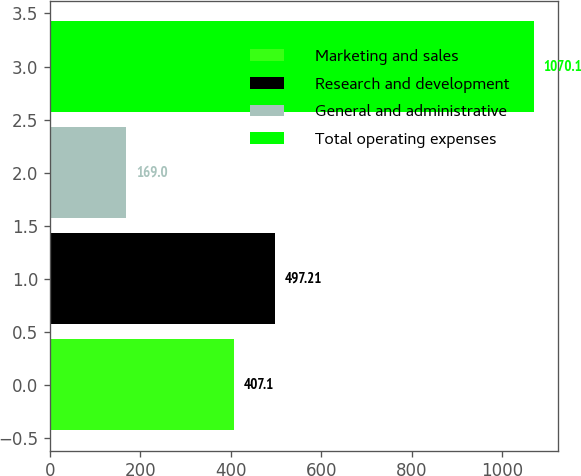<chart> <loc_0><loc_0><loc_500><loc_500><bar_chart><fcel>Marketing and sales<fcel>Research and development<fcel>General and administrative<fcel>Total operating expenses<nl><fcel>407.1<fcel>497.21<fcel>169<fcel>1070.1<nl></chart> 